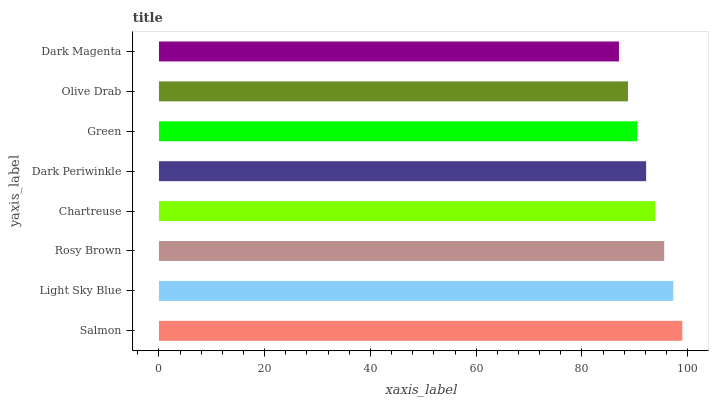Is Dark Magenta the minimum?
Answer yes or no. Yes. Is Salmon the maximum?
Answer yes or no. Yes. Is Light Sky Blue the minimum?
Answer yes or no. No. Is Light Sky Blue the maximum?
Answer yes or no. No. Is Salmon greater than Light Sky Blue?
Answer yes or no. Yes. Is Light Sky Blue less than Salmon?
Answer yes or no. Yes. Is Light Sky Blue greater than Salmon?
Answer yes or no. No. Is Salmon less than Light Sky Blue?
Answer yes or no. No. Is Chartreuse the high median?
Answer yes or no. Yes. Is Dark Periwinkle the low median?
Answer yes or no. Yes. Is Salmon the high median?
Answer yes or no. No. Is Light Sky Blue the low median?
Answer yes or no. No. 